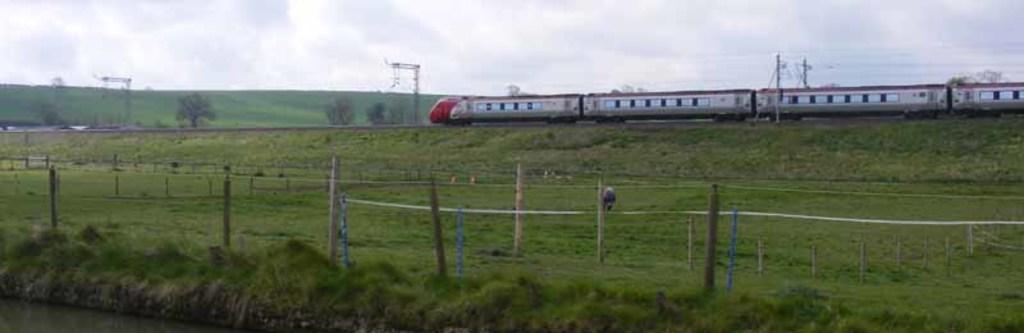In one or two sentences, can you explain what this image depicts? In this picture we can see the grass, poles, train, trees, some objects and in the background we can see the sky. 